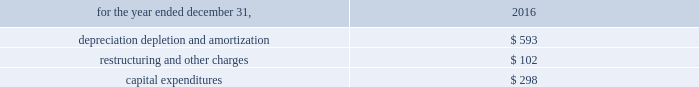On november 1 , 2016 , management evaluated the net assets of alcoa corporation for potential impairment and determined that no impairment charge was required .
The cash flows related to alcoa corporation have not been segregated and are included in the statement of consolidated cash flows for 2016 .
The table presents depreciation , depletion and amortization , restructuring and other charges , and purchases of property , plant and equipment of the discontinued operations related to alcoa corporation: .
Subsequent events management evaluated all activity of arconic and concluded that no subsequent events have occurred that would require recognition in the consolidated financial statements or disclosure in the notes to the consolidated financial statements , except as noted below : on january 22 , 2019 , the company announced that its board of directors ( the board ) had determined to no longer pursue a potential sale of arconic as part of its strategy and portfolio review .
On february 6 , 2019 , the company announced that the board appointed john c .
Plant , current chairman of the board , as chairman and chief executive officer of the company , effective february 6 , 2019 , to succeed chip blankenship , who ceased to serve as chief executive officer of the company and resigned as a member of the board , in each case as of that date .
In addition , the company announced that the board appointed elmer l .
Doty , current member of the board , as president and chief operating officer , a newly created position , effective february 6 , 2019 .
Mr .
Doty will remain a member of the board .
The company also announced that arthur d .
Collins , jr. , current member of the board , has been appointed interim lead independent director of the company , effective february 6 , 2019 .
On february 8 , 2019 , the company announced the following key initiatives as part of its ongoing strategy and portfolio review : plans to reduce operating costs , designed to maximize the impact in 2019 ; the planned separation of its portfolio into engineered products and forgings ( ep&f ) and global rolled products ( grp ) , with a spin-off of one of the businesses ; the potential sale of businesses that do not best fit into ep&f or grp ; execute its previously authorized $ 500 share repurchase program in the first half of 2019 ; the board authorized an additional $ 500 of share repurchases , effective through the end of 2020 ; and plans to reduce its quarterly common stock dividend from $ 0.06 to $ 0.02 per share .
On february 19 , 2019 , the company entered into an accelerated share repurchase ( 201casr 201d ) agreement with jpmorgan chase bank to repurchase $ 700 of its common stock , pursuant to the share repurchase program previously authorized by the board .
Under the asr agreement , arconic will receive initial delivery of approximately 32 million shares on february 21 , 2019 .
The final number of shares to be repurchased will be based on the volume-weighted average price of arconic 2019s common stock during the term of the transaction , less a discount .
The asr agreement is expected to be completed during the first half of the company will evaluate its organizational structure in conjunction with the planned separation of its portfolio and changes to its reportable segments are expected in the first half of 2019. .
How bigger are the expenses with depreciation depletion and amortization as a percent of capital expenditures in 2016? 
Rationale: it is the depreciation depletion and amortization expenses divided by capital expenditures , then subtracted 1 , which is going to represent the percentual increase of the depreciation depletion and amortization concerning the capital expenditures expenses .
Computations: ((593 / 298) - 1)
Answer: 0.98993. 